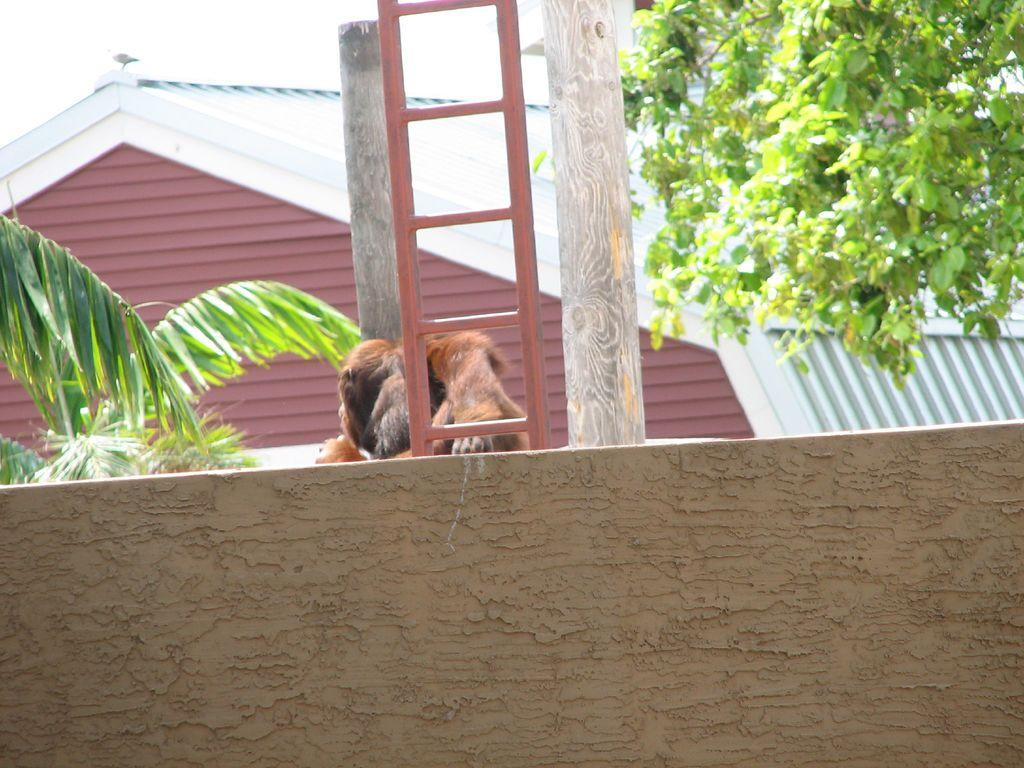What is the main subject in the center of the image? There is an animal in the center of the image. What object can be seen in the image that is typically used for climbing or reaching higher places? There is a ladder in the image. What type of furniture or storage container is present in the image? There is a wooden trunk in the image. What type of natural vegetation can be seen in the image? There are trees in the image. What type of structure can be seen in the image? There is a house in the image. What architectural feature is present at the bottom of the image? There is a wall at the bottom of the image. What part of the natural environment is visible in the image? The sky is visible at the top of the image. What type of arch can be seen in the image? There is no arch present in the image. What type of vein can be seen in the image? There are no veins present in the image, as it is a photograph of an outdoor scene. 